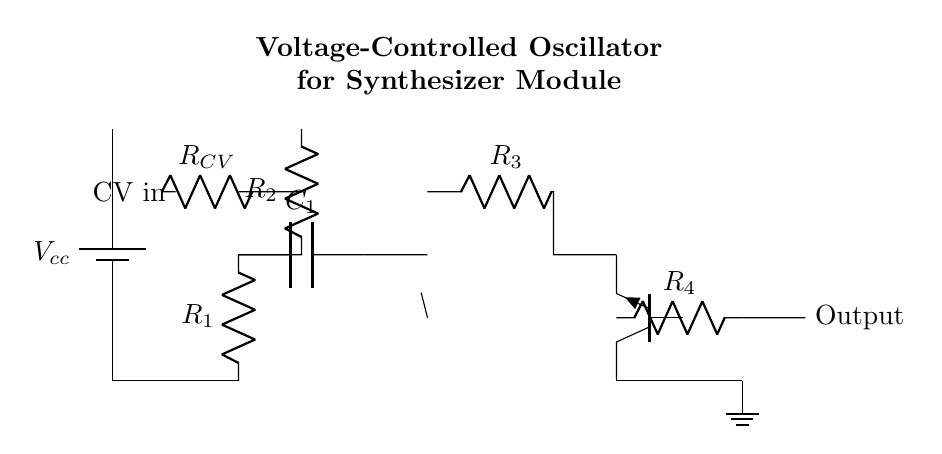What is the control voltage input in the circuit? The control voltage input is labeled as "CV in," which is indicated by the connection on the left side of the circuit diagram.
Answer: CV in What type of transistor is used in this circuit? The transistor is labeled as "npn," which indicates that it is a negative-positive-negative bipolar junction transistor.
Answer: npn What is the purpose of the capacitor C1 in this oscillator circuit? The capacitor C1 is used to store charge and influence the timing characteristics of the oscillator by affecting the frequency of oscillation.
Answer: Timing control How many resistors are present in the circuit? By counting the resistors labeled as R1, R2, R3, and R4, there are a total of four resistors present in this circuit.
Answer: 4 What does the output of this circuit provide? The output provides the signal produced by the oscillator, which can be used in synthesizers or sound modulation.
Answer: Signal output Why is the op-amp used in this oscillator circuit? The op-amp amplifies the signal and helps in the feedback loop, which is crucial for generating the oscillation.
Answer: Signal amplification What is the type of voltage source in this circuit? The voltage source is labeled as "battery," which indicates it is providing direct current power to the circuit.
Answer: Battery 